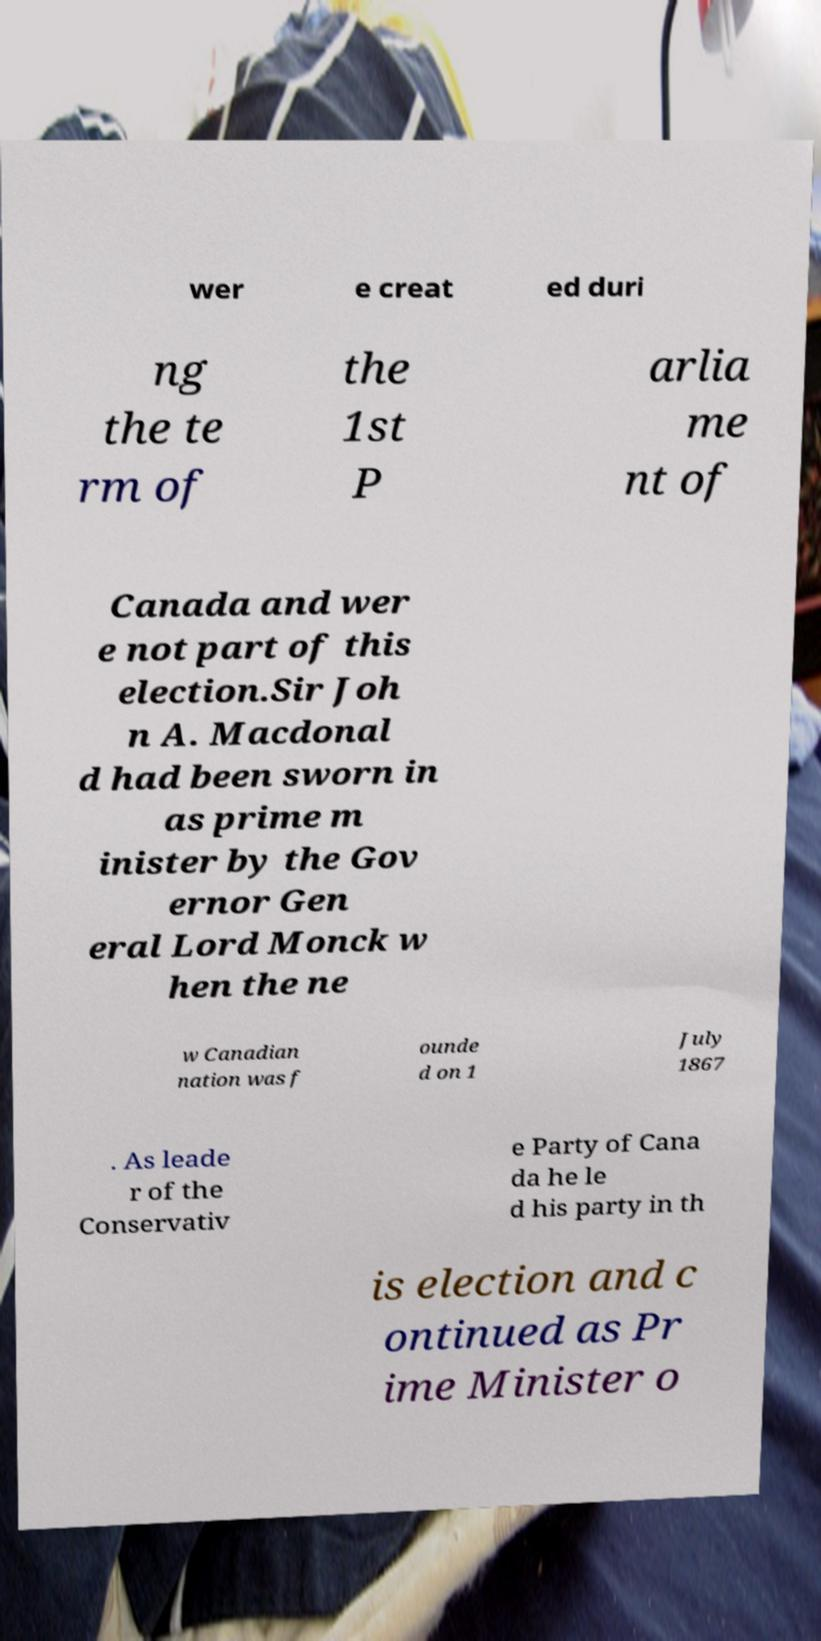For documentation purposes, I need the text within this image transcribed. Could you provide that? wer e creat ed duri ng the te rm of the 1st P arlia me nt of Canada and wer e not part of this election.Sir Joh n A. Macdonal d had been sworn in as prime m inister by the Gov ernor Gen eral Lord Monck w hen the ne w Canadian nation was f ounde d on 1 July 1867 . As leade r of the Conservativ e Party of Cana da he le d his party in th is election and c ontinued as Pr ime Minister o 